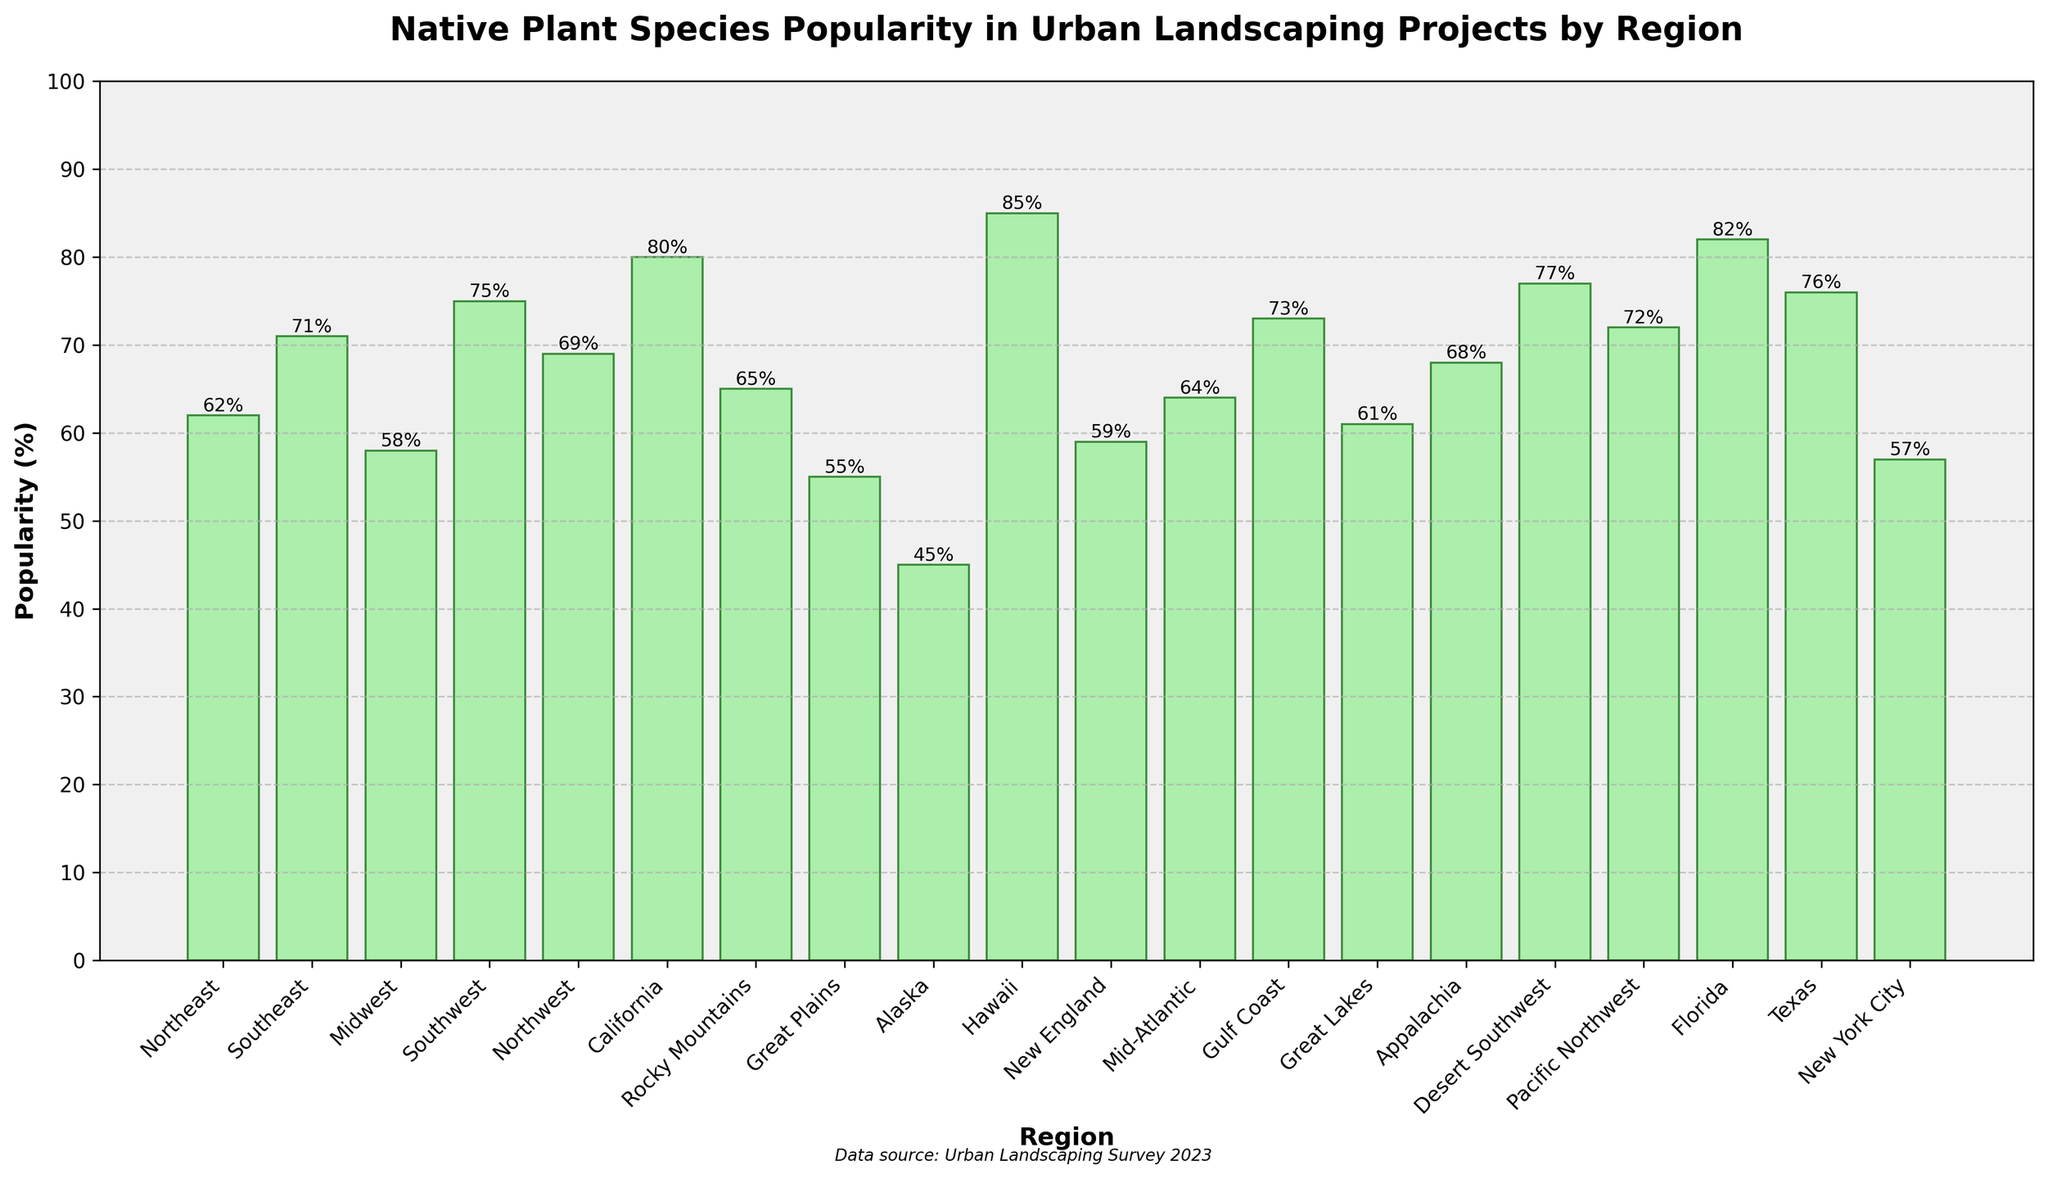Which region has the highest popularity of native plant species in urban landscaping projects? By observing the heights of the bars, Hawaii has the tallest bar, indicative of the highest popularity at 85%.
Answer: Hawaii What is the difference in popularity between the region with the highest and the lowest values? Hawaii has the highest value at 85%, and Alaska has the lowest value at 45%. The difference is 85 - 45.
Answer: 40% How many regions have a popularity of native plant species above 70%? Identify bars with values over 70%: Southeast, Southwest, California, Hawaii, Gulf Coast, Desert Southwest, Pacific Northwest, Florida, and Texas. Count them to get the total number.
Answer: 9 regions Which region has a higher popularity of native plant species, Northeast or Great Lakes? Compare the heights of the bars for the Northeast (62%) and Great Lakes (61%). Northeast is slightly higher.
Answer: Northeast What is the average popularity of native plant species in the Midwest and Great Plains? Add the values for Midwest (58%) and Great Plains (55%), then divide by 2 to find the average: (58 + 55)/2.
Answer: 56.5% What is the total popularity percentage if combining New York City, Mid-Atlantic, and Appalachia? Add the values for New York City (57%), Mid-Atlantic (64%), and Appalachia (68%) to get the total: 57 + 64 + 68.
Answer: 189% Which regions have a popularity exactly between 60% and 70%? Identify bars with values falling between 60% and 70%: Northeast (62%), Northwest (69%), New England (59% - does not qualify), Great Lakes (61%), Appalachia (68%), Mid-Atlantic (64%).
Answer: Northeast, Northwest, Great Lakes, Appalachia, Mid-Atlantic By how much does California exceed the average popularity across all regions? First, calculate the average by summing all percentages and dividing by the number of regions. Sum is 1342%, average is 1342/20 = 67.1%. California’s popularity is 80%. The difference is 80 - 67.1.
Answer: 12.9% What is the popularity gap between the Southeast and Pacific Northwest regions? Southeast has a popularity of 71%, and Pacific Northwest is at 72%. The gap is 72 - 71.
Answer: 1% 